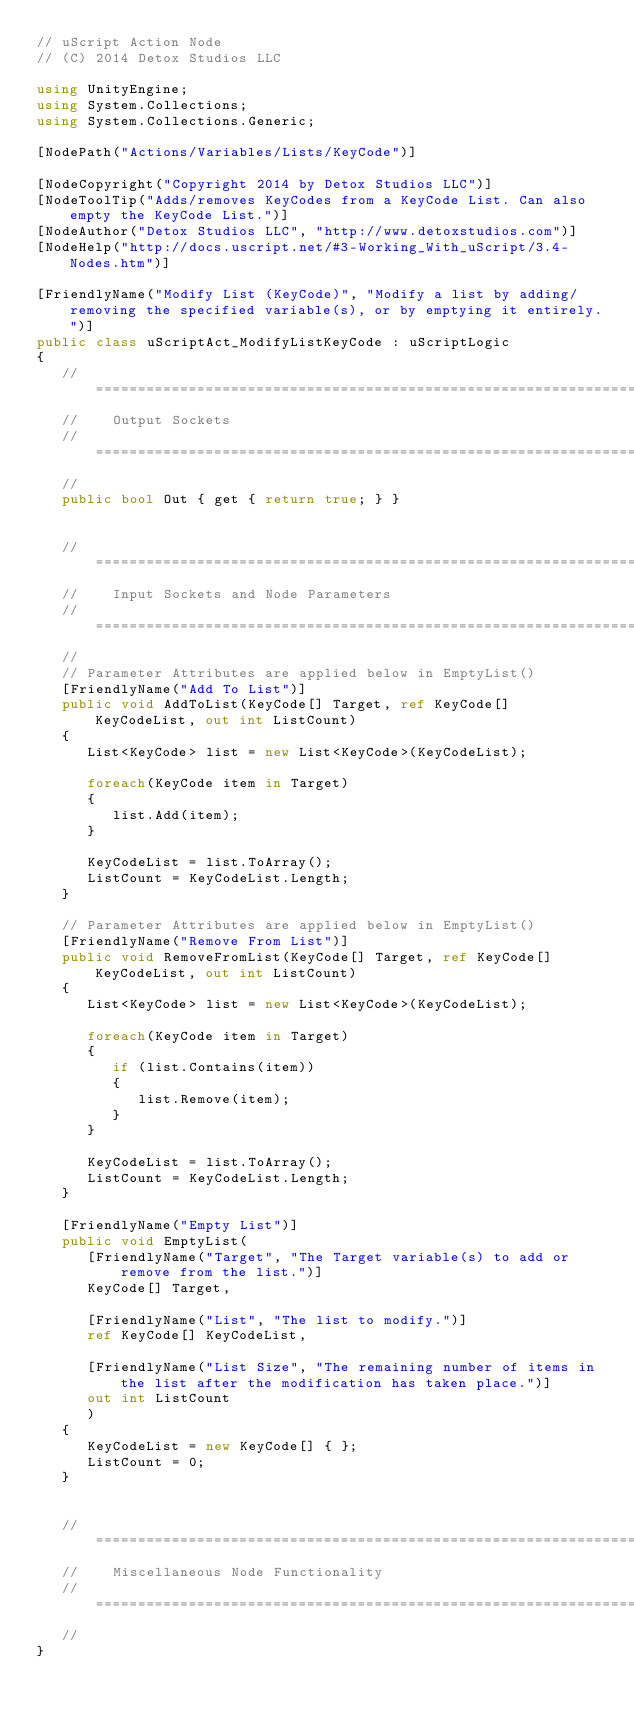<code> <loc_0><loc_0><loc_500><loc_500><_C#_>// uScript Action Node
// (C) 2014 Detox Studios LLC

using UnityEngine;
using System.Collections;
using System.Collections.Generic;

[NodePath("Actions/Variables/Lists/KeyCode")]

[NodeCopyright("Copyright 2014 by Detox Studios LLC")]
[NodeToolTip("Adds/removes KeyCodes from a KeyCode List. Can also empty the KeyCode List.")]
[NodeAuthor("Detox Studios LLC", "http://www.detoxstudios.com")]
[NodeHelp("http://docs.uscript.net/#3-Working_With_uScript/3.4-Nodes.htm")]

[FriendlyName("Modify List (KeyCode)", "Modify a list by adding/removing the specified variable(s), or by emptying it entirely.")]
public class uScriptAct_ModifyListKeyCode : uScriptLogic
{
   // ================================================================================
   //    Output Sockets
   // ================================================================================
   //
   public bool Out { get { return true; } }
    

   // ================================================================================
   //    Input Sockets and Node Parameters
   // ================================================================================
   //
   // Parameter Attributes are applied below in EmptyList()
   [FriendlyName("Add To List")]
   public void AddToList(KeyCode[] Target, ref KeyCode[] KeyCodeList, out int ListCount)
   {
      List<KeyCode> list = new List<KeyCode>(KeyCodeList);
      
      foreach(KeyCode item in Target)
      {
         list.Add(item);
      }

      KeyCodeList = list.ToArray();
      ListCount = KeyCodeList.Length;
   }

   // Parameter Attributes are applied below in EmptyList()
   [FriendlyName("Remove From List")]
   public void RemoveFromList(KeyCode[] Target, ref KeyCode[] KeyCodeList, out int ListCount)
   {
      List<KeyCode> list = new List<KeyCode>(KeyCodeList);
      
      foreach(KeyCode item in Target)
      {
         if (list.Contains(item))
         {
            list.Remove(item);
         }
      }

      KeyCodeList = list.ToArray();
      ListCount = KeyCodeList.Length;
   }

   [FriendlyName("Empty List")]
   public void EmptyList(
      [FriendlyName("Target", "The Target variable(s) to add or remove from the list.")]
      KeyCode[] Target,

      [FriendlyName("List", "The list to modify.")]
      ref KeyCode[] KeyCodeList,

      [FriendlyName("List Size", "The remaining number of items in the list after the modification has taken place.")]
      out int ListCount
      )
   {
      KeyCodeList = new KeyCode[] { };
      ListCount = 0;
   }


   // ================================================================================
   //    Miscellaneous Node Functionality
   // ================================================================================
   //
}
</code> 